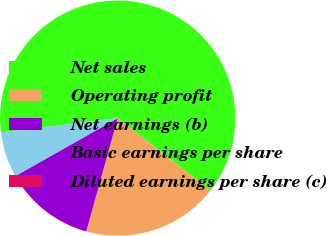Convert chart. <chart><loc_0><loc_0><loc_500><loc_500><pie_chart><fcel>Net sales<fcel>Operating profit<fcel>Net earnings (b)<fcel>Basic earnings per share<fcel>Diluted earnings per share (c)<nl><fcel>62.48%<fcel>18.75%<fcel>12.5%<fcel>6.26%<fcel>0.01%<nl></chart> 